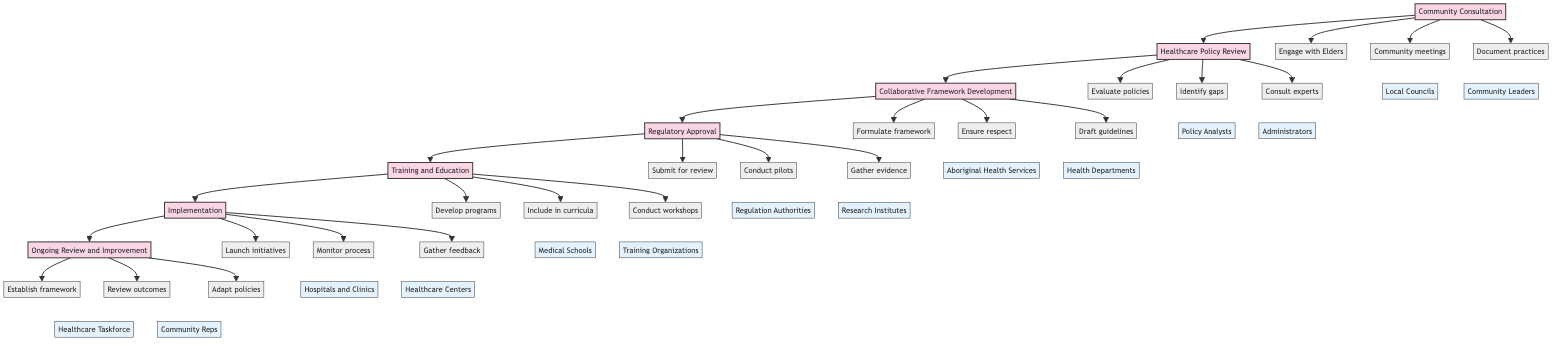What stage follows Community Consultation? The diagram shows that the next stage after Community Consultation is Healthcare Policy Review, which is directly connected with an arrow from the former to the latter.
Answer: Healthcare Policy Review How many actions are there in the Implementation stage? In the Implementation stage, there are three actions indicated: Launch integration initiatives, Monitor and evaluate the implementation process, and Gather feedback and make necessary adjustments. This is counted directly from the nodes connected to the Implementation stage.
Answer: 3 Which stakeholders are involved in the Regulatory Approval stage? The stakeholders associated with the Regulatory Approval stage, as indicated in the diagram, are Health Regulation Authorities and Medical Research Institutes, which are linked to the actions of this stage.
Answer: Health Regulation Authorities, Medical Research Institutes What action is performed right before Training and Education stage? The action performed right before the Training and Education stage is Conduct pilot programs and case studies, as it is the last action connected to the Regulatory Approval stage before transitioning to Training and Education.
Answer: Conduct pilot programs and case studies Which stage has a direct relationship with community leaders? The Community Consultation stage has a direct relationship with community leaders as shown in the diagram where actions in this stage are linked to stakeholders including Community Leaders.
Answer: Community Consultation What is the purpose of Ongoing Review and Improvement stage? The purpose of the Ongoing Review and Improvement stage, as described by the actions listed, is to establish a monitoring and evaluation framework, regularly review outcomes and impacts, and adapt policies and practices based on feedback. These aspects collectively define the stage's intent.
Answer: Establish a monitoring and evaluation framework, regularly review outcomes and impact, adapt policies and practices Name one action that is included in Healthcare Policy Review. One action included in the Healthcare Policy Review stage is Evaluate existing healthcare policies, as indicated in the diagram connecting to that particular stage.
Answer: Evaluate existing healthcare policies Which action comes immediately before the Collaborative Framework Development? According to the diagram, the action that comes immediately before Collaborative Framework Development is Identify gaps and opportunities for integration, which leads to the collaborative framework phase.
Answer: Identify gaps and opportunities for integration 